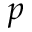Convert formula to latex. <formula><loc_0><loc_0><loc_500><loc_500>p</formula> 